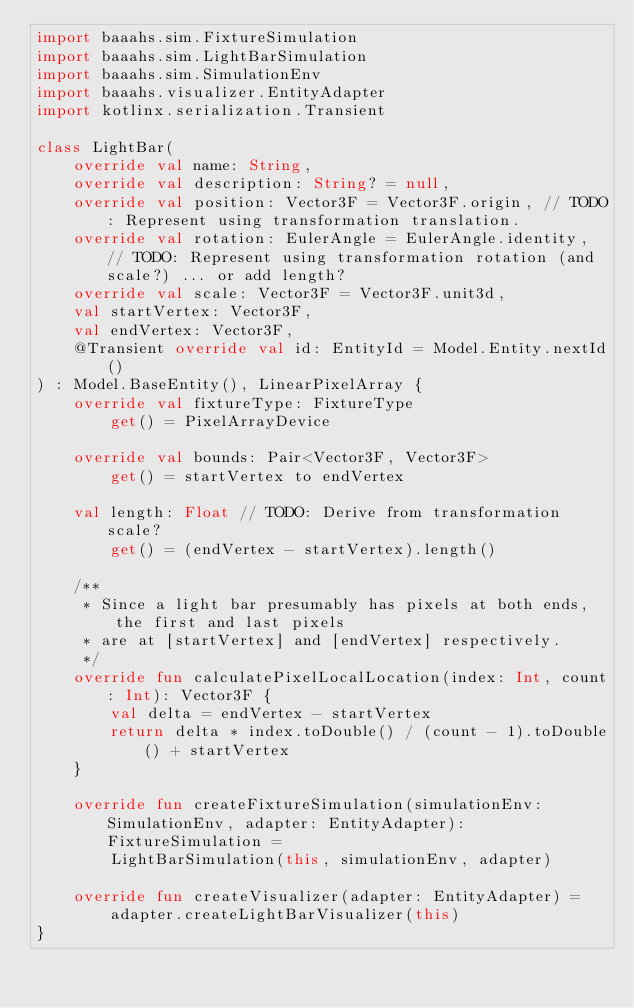Convert code to text. <code><loc_0><loc_0><loc_500><loc_500><_Kotlin_>import baaahs.sim.FixtureSimulation
import baaahs.sim.LightBarSimulation
import baaahs.sim.SimulationEnv
import baaahs.visualizer.EntityAdapter
import kotlinx.serialization.Transient

class LightBar(
    override val name: String,
    override val description: String? = null,
    override val position: Vector3F = Vector3F.origin, // TODO: Represent using transformation translation.
    override val rotation: EulerAngle = EulerAngle.identity, // TODO: Represent using transformation rotation (and scale?) ... or add length?
    override val scale: Vector3F = Vector3F.unit3d,
    val startVertex: Vector3F,
    val endVertex: Vector3F,
    @Transient override val id: EntityId = Model.Entity.nextId()
) : Model.BaseEntity(), LinearPixelArray {
    override val fixtureType: FixtureType
        get() = PixelArrayDevice

    override val bounds: Pair<Vector3F, Vector3F>
        get() = startVertex to endVertex

    val length: Float // TODO: Derive from transformation scale?
        get() = (endVertex - startVertex).length()

    /**
     * Since a light bar presumably has pixels at both ends, the first and last pixels
     * are at [startVertex] and [endVertex] respectively.
     */
    override fun calculatePixelLocalLocation(index: Int, count: Int): Vector3F {
        val delta = endVertex - startVertex
        return delta * index.toDouble() / (count - 1).toDouble() + startVertex
    }

    override fun createFixtureSimulation(simulationEnv: SimulationEnv, adapter: EntityAdapter): FixtureSimulation =
        LightBarSimulation(this, simulationEnv, adapter)

    override fun createVisualizer(adapter: EntityAdapter) =
        adapter.createLightBarVisualizer(this)
}
</code> 